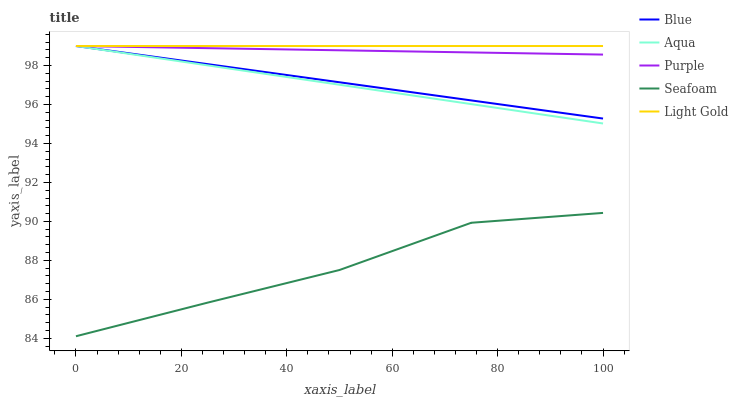Does Seafoam have the minimum area under the curve?
Answer yes or no. Yes. Does Light Gold have the maximum area under the curve?
Answer yes or no. Yes. Does Purple have the minimum area under the curve?
Answer yes or no. No. Does Purple have the maximum area under the curve?
Answer yes or no. No. Is Blue the smoothest?
Answer yes or no. Yes. Is Seafoam the roughest?
Answer yes or no. Yes. Is Aqua the smoothest?
Answer yes or no. No. Is Aqua the roughest?
Answer yes or no. No. Does Seafoam have the lowest value?
Answer yes or no. Yes. Does Purple have the lowest value?
Answer yes or no. No. Does Aqua have the highest value?
Answer yes or no. Yes. Does Seafoam have the highest value?
Answer yes or no. No. Is Seafoam less than Purple?
Answer yes or no. Yes. Is Light Gold greater than Seafoam?
Answer yes or no. Yes. Does Aqua intersect Light Gold?
Answer yes or no. Yes. Is Aqua less than Light Gold?
Answer yes or no. No. Is Aqua greater than Light Gold?
Answer yes or no. No. Does Seafoam intersect Purple?
Answer yes or no. No. 